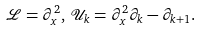<formula> <loc_0><loc_0><loc_500><loc_500>\mathcal { L } = \partial _ { x } ^ { 2 } , \, \mathcal { U } _ { k } = \partial _ { x } ^ { 2 } \partial _ { k } - \partial _ { k + 1 } .</formula> 